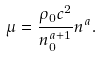Convert formula to latex. <formula><loc_0><loc_0><loc_500><loc_500>\mu = \frac { \rho _ { 0 } c ^ { 2 } } { n _ { 0 } ^ { a + 1 } } n ^ { a } .</formula> 